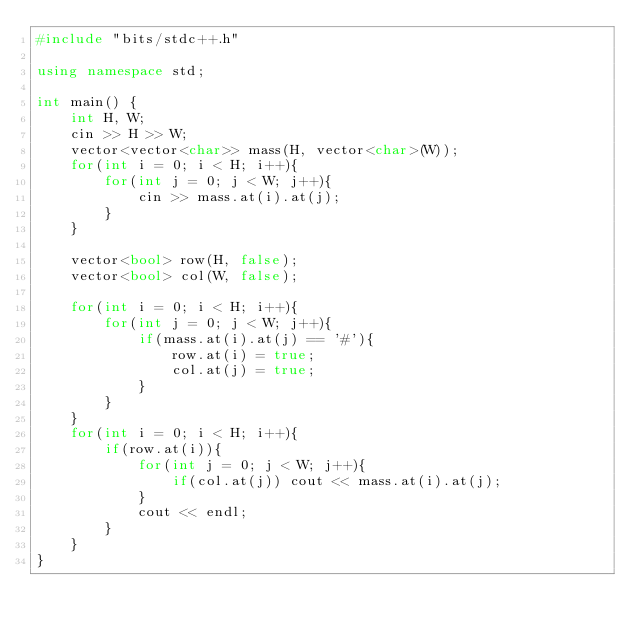Convert code to text. <code><loc_0><loc_0><loc_500><loc_500><_C++_>#include "bits/stdc++.h"

using namespace std;

int main() {
    int H, W;
    cin >> H >> W;
    vector<vector<char>> mass(H, vector<char>(W));
    for(int i = 0; i < H; i++){
        for(int j = 0; j < W; j++){
            cin >> mass.at(i).at(j);
        }
    }

    vector<bool> row(H, false);
    vector<bool> col(W, false);

    for(int i = 0; i < H; i++){
        for(int j = 0; j < W; j++){
            if(mass.at(i).at(j) == '#'){
                row.at(i) = true;
                col.at(j) = true;
            }
        }
    }
    for(int i = 0; i < H; i++){
        if(row.at(i)){
            for(int j = 0; j < W; j++){
                if(col.at(j)) cout << mass.at(i).at(j);
            }
            cout << endl;
        }
    }
}</code> 